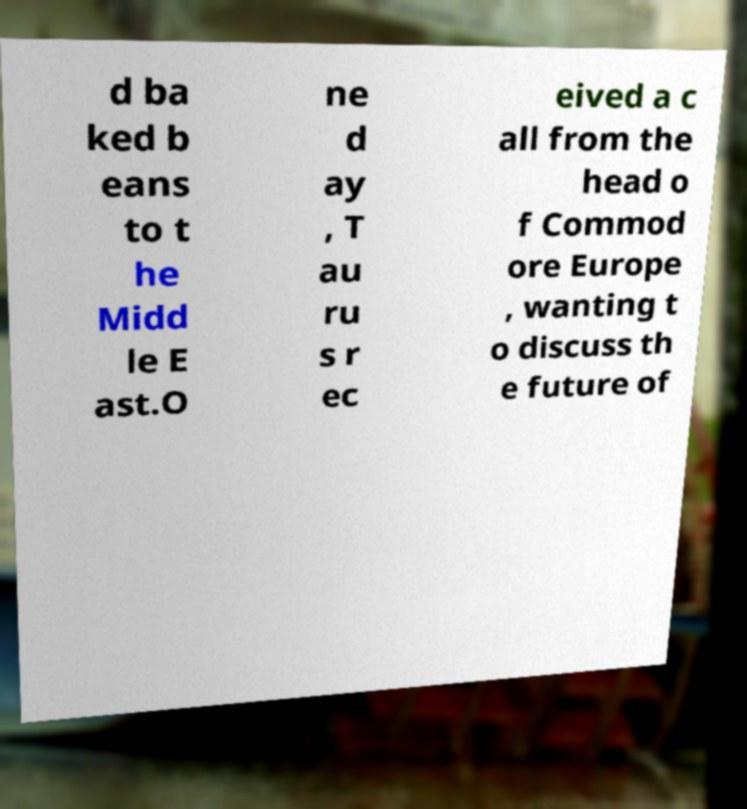Please read and relay the text visible in this image. What does it say? d ba ked b eans to t he Midd le E ast.O ne d ay , T au ru s r ec eived a c all from the head o f Commod ore Europe , wanting t o discuss th e future of 